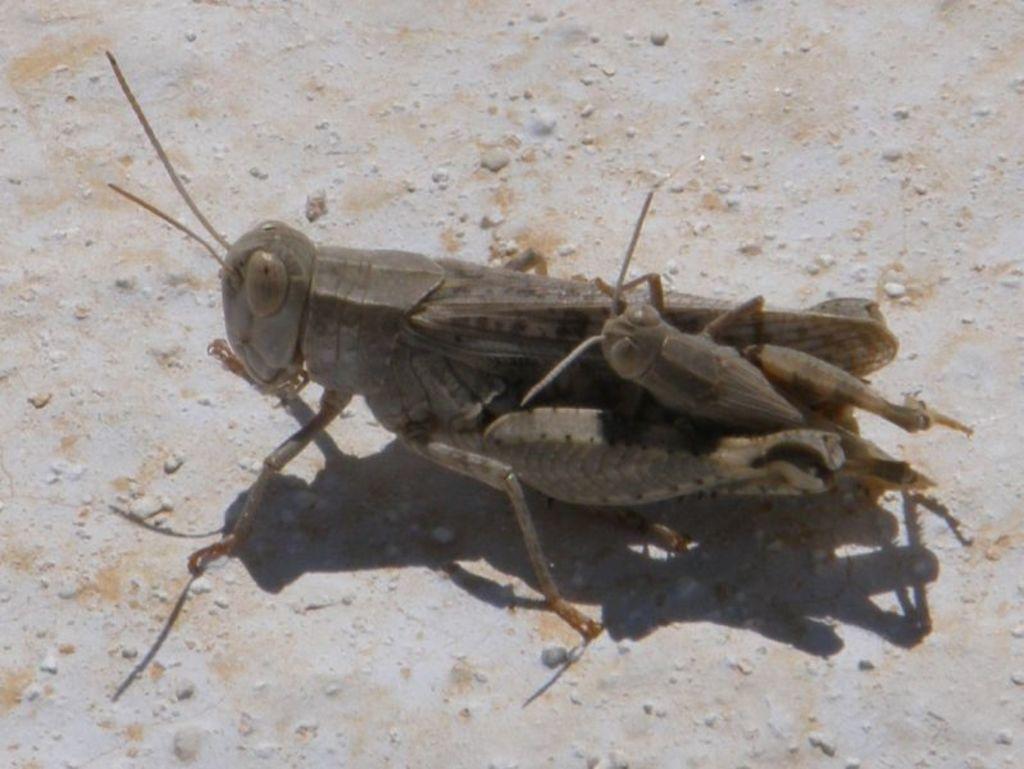Could you give a brief overview of what you see in this image? In this image, we can see some insects on the surface. 